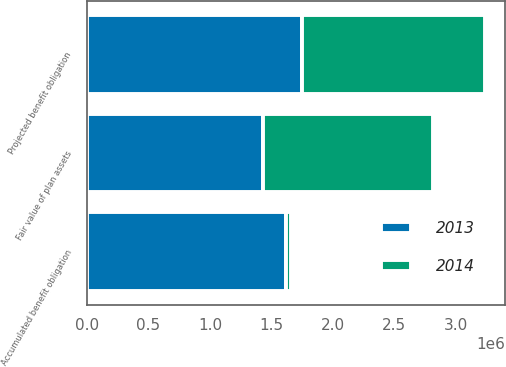Convert chart to OTSL. <chart><loc_0><loc_0><loc_500><loc_500><stacked_bar_chart><ecel><fcel>Projected benefit obligation<fcel>Fair value of plan assets<fcel>Accumulated benefit obligation<nl><fcel>2013<fcel>1.746e+06<fcel>1.428e+06<fcel>1.616e+06<nl><fcel>2014<fcel>1.494e+06<fcel>1.384e+06<fcel>43000<nl></chart> 